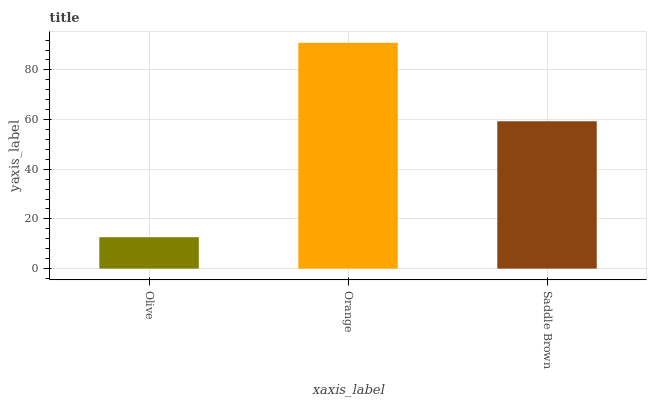Is Olive the minimum?
Answer yes or no. Yes. Is Orange the maximum?
Answer yes or no. Yes. Is Saddle Brown the minimum?
Answer yes or no. No. Is Saddle Brown the maximum?
Answer yes or no. No. Is Orange greater than Saddle Brown?
Answer yes or no. Yes. Is Saddle Brown less than Orange?
Answer yes or no. Yes. Is Saddle Brown greater than Orange?
Answer yes or no. No. Is Orange less than Saddle Brown?
Answer yes or no. No. Is Saddle Brown the high median?
Answer yes or no. Yes. Is Saddle Brown the low median?
Answer yes or no. Yes. Is Olive the high median?
Answer yes or no. No. Is Orange the low median?
Answer yes or no. No. 